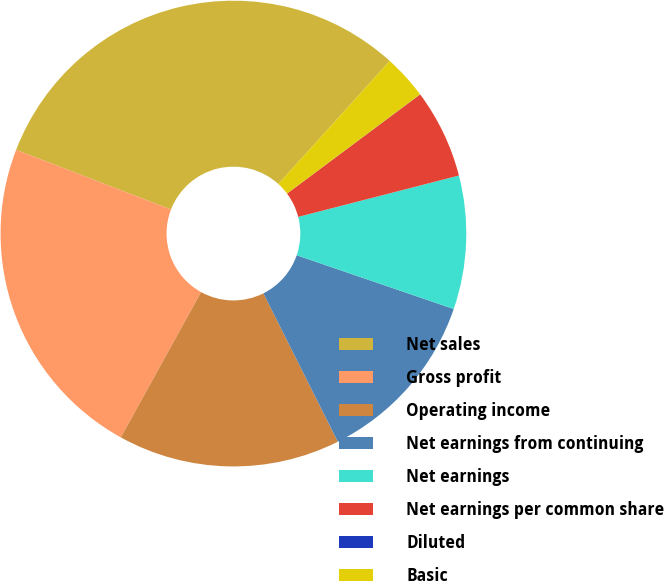Convert chart to OTSL. <chart><loc_0><loc_0><loc_500><loc_500><pie_chart><fcel>Net sales<fcel>Gross profit<fcel>Operating income<fcel>Net earnings from continuing<fcel>Net earnings<fcel>Net earnings per common share<fcel>Diluted<fcel>Basic<nl><fcel>30.86%<fcel>22.82%<fcel>15.43%<fcel>12.35%<fcel>9.26%<fcel>6.18%<fcel>0.01%<fcel>3.09%<nl></chart> 